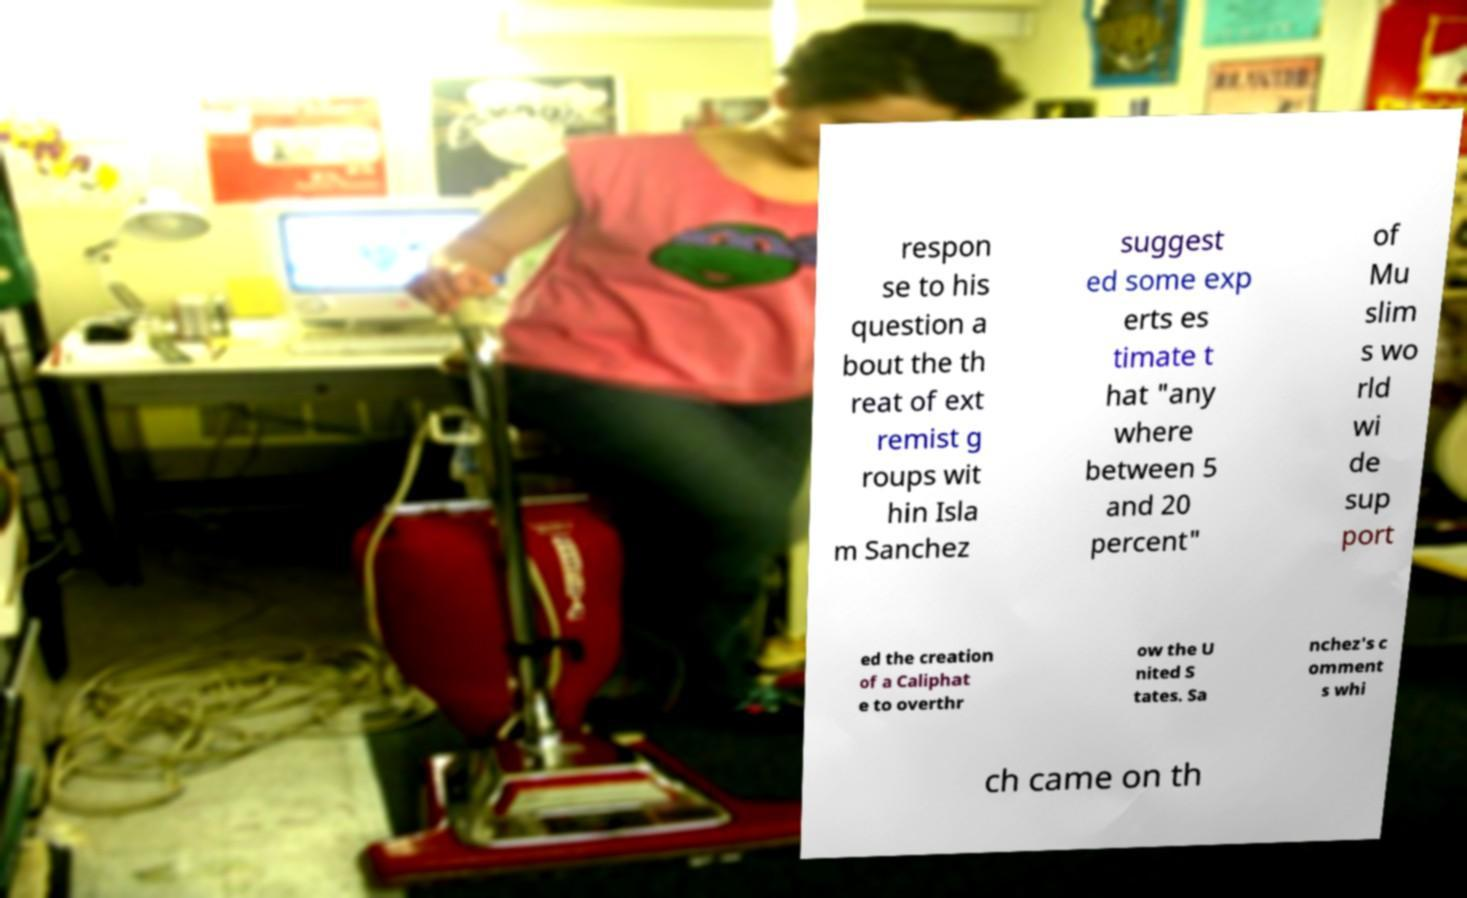For documentation purposes, I need the text within this image transcribed. Could you provide that? respon se to his question a bout the th reat of ext remist g roups wit hin Isla m Sanchez suggest ed some exp erts es timate t hat "any where between 5 and 20 percent" of Mu slim s wo rld wi de sup port ed the creation of a Caliphat e to overthr ow the U nited S tates. Sa nchez's c omment s whi ch came on th 